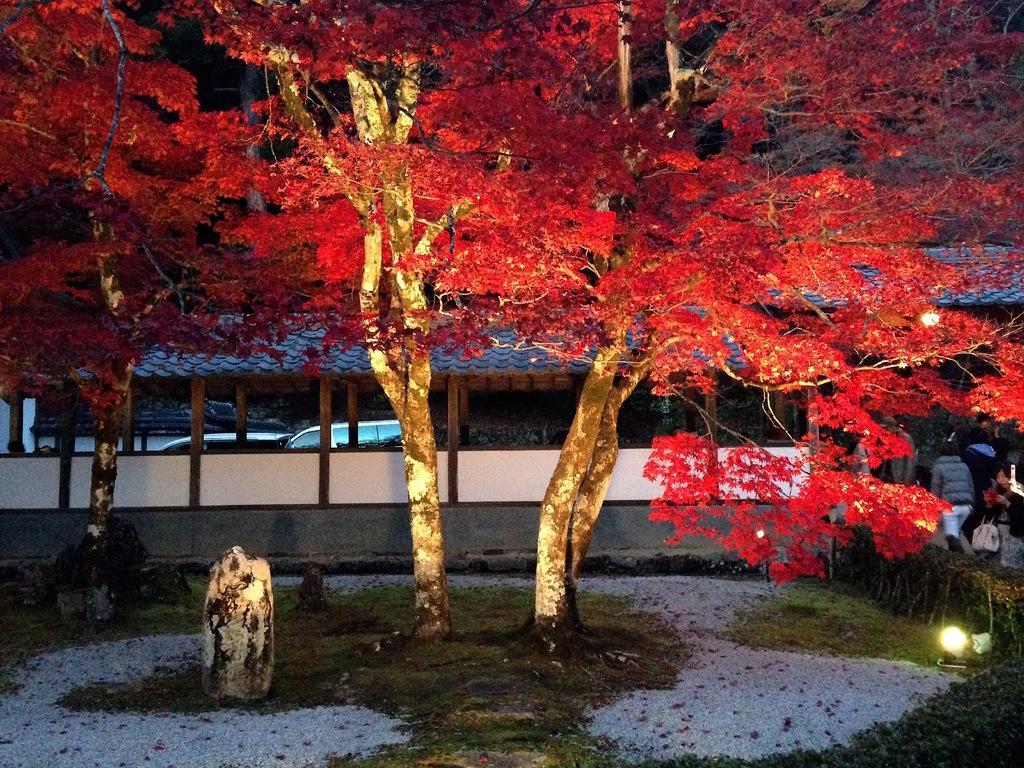Describe this image in one or two sentences. We can see grass,trees and lights. In the background we can see people,shed,wall and vehicles. 